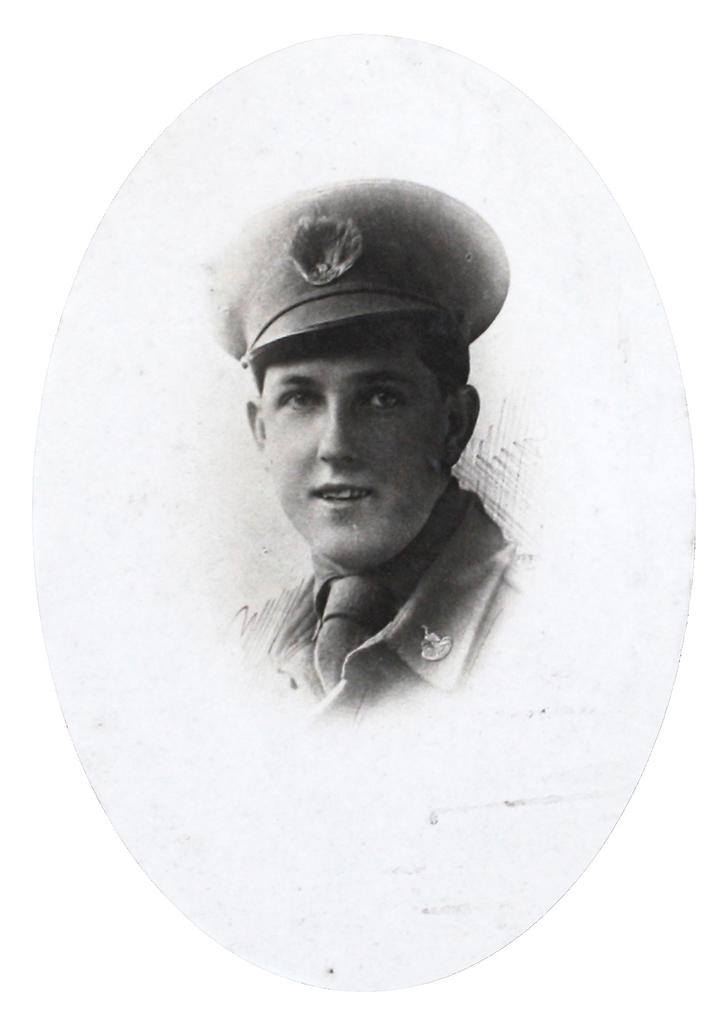What is present in the image? There is a person in the image. How is the person's expression in the image? The person is smiling. What type of cart is being pushed by the person in the image? There is no cart present in the image; only a person is visible. 